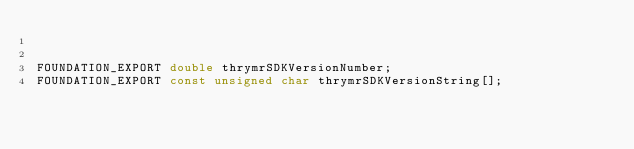<code> <loc_0><loc_0><loc_500><loc_500><_C_>

FOUNDATION_EXPORT double thrymrSDKVersionNumber;
FOUNDATION_EXPORT const unsigned char thrymrSDKVersionString[];

</code> 